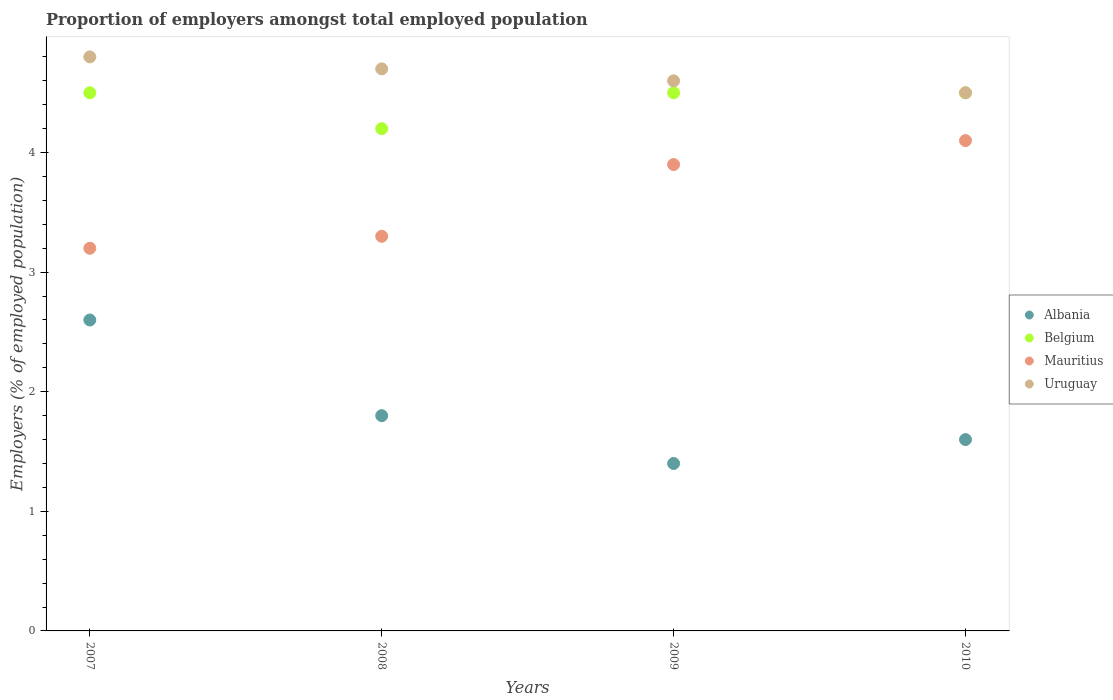How many different coloured dotlines are there?
Your answer should be compact. 4. Is the number of dotlines equal to the number of legend labels?
Your answer should be compact. Yes. What is the proportion of employers in Belgium in 2008?
Offer a very short reply. 4.2. Across all years, what is the maximum proportion of employers in Uruguay?
Offer a terse response. 4.8. What is the total proportion of employers in Mauritius in the graph?
Make the answer very short. 14.5. What is the difference between the proportion of employers in Uruguay in 2007 and that in 2008?
Keep it short and to the point. 0.1. What is the difference between the proportion of employers in Uruguay in 2008 and the proportion of employers in Albania in 2009?
Make the answer very short. 3.3. What is the average proportion of employers in Belgium per year?
Offer a terse response. 4.42. In the year 2007, what is the difference between the proportion of employers in Uruguay and proportion of employers in Mauritius?
Your response must be concise. 1.6. In how many years, is the proportion of employers in Uruguay greater than 3.4 %?
Your answer should be compact. 4. What is the ratio of the proportion of employers in Uruguay in 2007 to that in 2009?
Your answer should be very brief. 1.04. Is the proportion of employers in Albania in 2007 less than that in 2010?
Provide a short and direct response. No. What is the difference between the highest and the second highest proportion of employers in Albania?
Make the answer very short. 0.8. What is the difference between the highest and the lowest proportion of employers in Uruguay?
Offer a terse response. 0.3. In how many years, is the proportion of employers in Albania greater than the average proportion of employers in Albania taken over all years?
Your answer should be very brief. 1. Is it the case that in every year, the sum of the proportion of employers in Albania and proportion of employers in Mauritius  is greater than the sum of proportion of employers in Belgium and proportion of employers in Uruguay?
Keep it short and to the point. No. Is the proportion of employers in Mauritius strictly greater than the proportion of employers in Uruguay over the years?
Ensure brevity in your answer.  No. How many years are there in the graph?
Make the answer very short. 4. What is the title of the graph?
Make the answer very short. Proportion of employers amongst total employed population. Does "Bangladesh" appear as one of the legend labels in the graph?
Give a very brief answer. No. What is the label or title of the X-axis?
Keep it short and to the point. Years. What is the label or title of the Y-axis?
Provide a succinct answer. Employers (% of employed population). What is the Employers (% of employed population) in Albania in 2007?
Your answer should be very brief. 2.6. What is the Employers (% of employed population) of Mauritius in 2007?
Ensure brevity in your answer.  3.2. What is the Employers (% of employed population) in Uruguay in 2007?
Your response must be concise. 4.8. What is the Employers (% of employed population) in Albania in 2008?
Keep it short and to the point. 1.8. What is the Employers (% of employed population) in Belgium in 2008?
Your response must be concise. 4.2. What is the Employers (% of employed population) of Mauritius in 2008?
Keep it short and to the point. 3.3. What is the Employers (% of employed population) in Uruguay in 2008?
Give a very brief answer. 4.7. What is the Employers (% of employed population) of Albania in 2009?
Provide a succinct answer. 1.4. What is the Employers (% of employed population) of Mauritius in 2009?
Ensure brevity in your answer.  3.9. What is the Employers (% of employed population) of Uruguay in 2009?
Offer a very short reply. 4.6. What is the Employers (% of employed population) in Albania in 2010?
Your answer should be very brief. 1.6. What is the Employers (% of employed population) in Belgium in 2010?
Provide a short and direct response. 4.5. What is the Employers (% of employed population) in Mauritius in 2010?
Your answer should be compact. 4.1. Across all years, what is the maximum Employers (% of employed population) in Albania?
Your answer should be very brief. 2.6. Across all years, what is the maximum Employers (% of employed population) in Belgium?
Provide a succinct answer. 4.5. Across all years, what is the maximum Employers (% of employed population) in Mauritius?
Offer a terse response. 4.1. Across all years, what is the maximum Employers (% of employed population) in Uruguay?
Your answer should be compact. 4.8. Across all years, what is the minimum Employers (% of employed population) of Albania?
Keep it short and to the point. 1.4. Across all years, what is the minimum Employers (% of employed population) in Belgium?
Provide a succinct answer. 4.2. Across all years, what is the minimum Employers (% of employed population) of Mauritius?
Your answer should be compact. 3.2. What is the total Employers (% of employed population) of Albania in the graph?
Ensure brevity in your answer.  7.4. What is the difference between the Employers (% of employed population) of Belgium in 2007 and that in 2008?
Make the answer very short. 0.3. What is the difference between the Employers (% of employed population) of Albania in 2007 and that in 2009?
Your response must be concise. 1.2. What is the difference between the Employers (% of employed population) in Belgium in 2007 and that in 2009?
Provide a succinct answer. 0. What is the difference between the Employers (% of employed population) in Mauritius in 2007 and that in 2009?
Give a very brief answer. -0.7. What is the difference between the Employers (% of employed population) of Mauritius in 2007 and that in 2010?
Your answer should be very brief. -0.9. What is the difference between the Employers (% of employed population) of Albania in 2008 and that in 2009?
Offer a very short reply. 0.4. What is the difference between the Employers (% of employed population) of Belgium in 2008 and that in 2009?
Make the answer very short. -0.3. What is the difference between the Employers (% of employed population) in Uruguay in 2008 and that in 2009?
Offer a terse response. 0.1. What is the difference between the Employers (% of employed population) of Uruguay in 2008 and that in 2010?
Your response must be concise. 0.2. What is the difference between the Employers (% of employed population) of Albania in 2007 and the Employers (% of employed population) of Mauritius in 2008?
Ensure brevity in your answer.  -0.7. What is the difference between the Employers (% of employed population) in Belgium in 2007 and the Employers (% of employed population) in Uruguay in 2008?
Provide a short and direct response. -0.2. What is the difference between the Employers (% of employed population) of Mauritius in 2007 and the Employers (% of employed population) of Uruguay in 2008?
Make the answer very short. -1.5. What is the difference between the Employers (% of employed population) in Albania in 2007 and the Employers (% of employed population) in Belgium in 2009?
Offer a terse response. -1.9. What is the difference between the Employers (% of employed population) in Albania in 2007 and the Employers (% of employed population) in Mauritius in 2009?
Offer a very short reply. -1.3. What is the difference between the Employers (% of employed population) of Albania in 2007 and the Employers (% of employed population) of Uruguay in 2009?
Ensure brevity in your answer.  -2. What is the difference between the Employers (% of employed population) of Albania in 2007 and the Employers (% of employed population) of Belgium in 2010?
Your response must be concise. -1.9. What is the difference between the Employers (% of employed population) in Albania in 2007 and the Employers (% of employed population) in Mauritius in 2010?
Make the answer very short. -1.5. What is the difference between the Employers (% of employed population) of Albania in 2007 and the Employers (% of employed population) of Uruguay in 2010?
Ensure brevity in your answer.  -1.9. What is the difference between the Employers (% of employed population) of Belgium in 2007 and the Employers (% of employed population) of Uruguay in 2010?
Your response must be concise. 0. What is the difference between the Employers (% of employed population) of Mauritius in 2007 and the Employers (% of employed population) of Uruguay in 2010?
Provide a short and direct response. -1.3. What is the difference between the Employers (% of employed population) in Albania in 2008 and the Employers (% of employed population) in Belgium in 2009?
Ensure brevity in your answer.  -2.7. What is the difference between the Employers (% of employed population) of Albania in 2008 and the Employers (% of employed population) of Mauritius in 2009?
Provide a succinct answer. -2.1. What is the difference between the Employers (% of employed population) of Albania in 2008 and the Employers (% of employed population) of Uruguay in 2009?
Make the answer very short. -2.8. What is the difference between the Employers (% of employed population) in Belgium in 2008 and the Employers (% of employed population) in Uruguay in 2009?
Your response must be concise. -0.4. What is the difference between the Employers (% of employed population) of Mauritius in 2008 and the Employers (% of employed population) of Uruguay in 2009?
Provide a short and direct response. -1.3. What is the difference between the Employers (% of employed population) of Albania in 2008 and the Employers (% of employed population) of Mauritius in 2010?
Offer a terse response. -2.3. What is the difference between the Employers (% of employed population) of Albania in 2008 and the Employers (% of employed population) of Uruguay in 2010?
Your response must be concise. -2.7. What is the difference between the Employers (% of employed population) in Belgium in 2008 and the Employers (% of employed population) in Mauritius in 2010?
Your response must be concise. 0.1. What is the difference between the Employers (% of employed population) of Albania in 2009 and the Employers (% of employed population) of Belgium in 2010?
Make the answer very short. -3.1. What is the difference between the Employers (% of employed population) of Mauritius in 2009 and the Employers (% of employed population) of Uruguay in 2010?
Ensure brevity in your answer.  -0.6. What is the average Employers (% of employed population) in Albania per year?
Provide a short and direct response. 1.85. What is the average Employers (% of employed population) of Belgium per year?
Your response must be concise. 4.42. What is the average Employers (% of employed population) in Mauritius per year?
Your answer should be very brief. 3.62. What is the average Employers (% of employed population) in Uruguay per year?
Provide a short and direct response. 4.65. In the year 2007, what is the difference between the Employers (% of employed population) of Albania and Employers (% of employed population) of Mauritius?
Your response must be concise. -0.6. In the year 2007, what is the difference between the Employers (% of employed population) of Albania and Employers (% of employed population) of Uruguay?
Offer a terse response. -2.2. In the year 2007, what is the difference between the Employers (% of employed population) of Belgium and Employers (% of employed population) of Mauritius?
Provide a succinct answer. 1.3. In the year 2007, what is the difference between the Employers (% of employed population) in Belgium and Employers (% of employed population) in Uruguay?
Your response must be concise. -0.3. In the year 2008, what is the difference between the Employers (% of employed population) of Albania and Employers (% of employed population) of Mauritius?
Keep it short and to the point. -1.5. In the year 2008, what is the difference between the Employers (% of employed population) of Albania and Employers (% of employed population) of Uruguay?
Keep it short and to the point. -2.9. In the year 2008, what is the difference between the Employers (% of employed population) of Belgium and Employers (% of employed population) of Mauritius?
Offer a terse response. 0.9. In the year 2008, what is the difference between the Employers (% of employed population) in Belgium and Employers (% of employed population) in Uruguay?
Keep it short and to the point. -0.5. In the year 2009, what is the difference between the Employers (% of employed population) in Albania and Employers (% of employed population) in Uruguay?
Give a very brief answer. -3.2. In the year 2009, what is the difference between the Employers (% of employed population) in Belgium and Employers (% of employed population) in Mauritius?
Make the answer very short. 0.6. In the year 2009, what is the difference between the Employers (% of employed population) of Belgium and Employers (% of employed population) of Uruguay?
Provide a succinct answer. -0.1. In the year 2010, what is the difference between the Employers (% of employed population) of Albania and Employers (% of employed population) of Mauritius?
Give a very brief answer. -2.5. In the year 2010, what is the difference between the Employers (% of employed population) of Belgium and Employers (% of employed population) of Uruguay?
Your answer should be compact. 0. What is the ratio of the Employers (% of employed population) in Albania in 2007 to that in 2008?
Offer a very short reply. 1.44. What is the ratio of the Employers (% of employed population) in Belgium in 2007 to that in 2008?
Your answer should be very brief. 1.07. What is the ratio of the Employers (% of employed population) of Mauritius in 2007 to that in 2008?
Your answer should be compact. 0.97. What is the ratio of the Employers (% of employed population) in Uruguay in 2007 to that in 2008?
Your response must be concise. 1.02. What is the ratio of the Employers (% of employed population) in Albania in 2007 to that in 2009?
Provide a succinct answer. 1.86. What is the ratio of the Employers (% of employed population) of Belgium in 2007 to that in 2009?
Offer a terse response. 1. What is the ratio of the Employers (% of employed population) in Mauritius in 2007 to that in 2009?
Give a very brief answer. 0.82. What is the ratio of the Employers (% of employed population) of Uruguay in 2007 to that in 2009?
Offer a terse response. 1.04. What is the ratio of the Employers (% of employed population) in Albania in 2007 to that in 2010?
Offer a very short reply. 1.62. What is the ratio of the Employers (% of employed population) of Mauritius in 2007 to that in 2010?
Your response must be concise. 0.78. What is the ratio of the Employers (% of employed population) in Uruguay in 2007 to that in 2010?
Your answer should be very brief. 1.07. What is the ratio of the Employers (% of employed population) in Albania in 2008 to that in 2009?
Provide a succinct answer. 1.29. What is the ratio of the Employers (% of employed population) in Belgium in 2008 to that in 2009?
Offer a terse response. 0.93. What is the ratio of the Employers (% of employed population) in Mauritius in 2008 to that in 2009?
Your answer should be compact. 0.85. What is the ratio of the Employers (% of employed population) of Uruguay in 2008 to that in 2009?
Offer a very short reply. 1.02. What is the ratio of the Employers (% of employed population) in Albania in 2008 to that in 2010?
Your answer should be compact. 1.12. What is the ratio of the Employers (% of employed population) of Mauritius in 2008 to that in 2010?
Your answer should be very brief. 0.8. What is the ratio of the Employers (% of employed population) in Uruguay in 2008 to that in 2010?
Your answer should be compact. 1.04. What is the ratio of the Employers (% of employed population) of Belgium in 2009 to that in 2010?
Provide a succinct answer. 1. What is the ratio of the Employers (% of employed population) in Mauritius in 2009 to that in 2010?
Your response must be concise. 0.95. What is the ratio of the Employers (% of employed population) of Uruguay in 2009 to that in 2010?
Keep it short and to the point. 1.02. What is the difference between the highest and the second highest Employers (% of employed population) of Belgium?
Provide a succinct answer. 0. What is the difference between the highest and the second highest Employers (% of employed population) in Uruguay?
Give a very brief answer. 0.1. What is the difference between the highest and the lowest Employers (% of employed population) of Albania?
Your answer should be compact. 1.2. What is the difference between the highest and the lowest Employers (% of employed population) in Belgium?
Provide a short and direct response. 0.3. What is the difference between the highest and the lowest Employers (% of employed population) in Uruguay?
Ensure brevity in your answer.  0.3. 